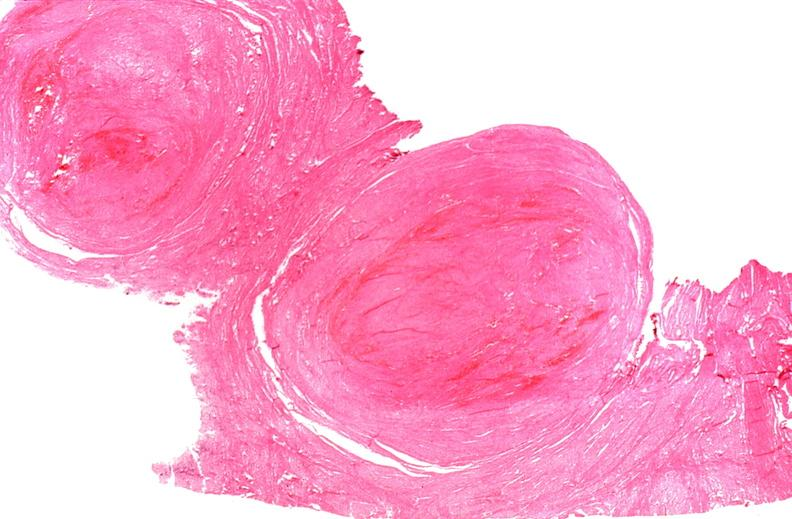s female reproductive present?
Answer the question using a single word or phrase. Yes 